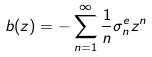Convert formula to latex. <formula><loc_0><loc_0><loc_500><loc_500>b ( z ) = - \sum _ { n = 1 } ^ { \infty } \frac { 1 } { n } \sigma _ { n } ^ { e } z ^ { n }</formula> 